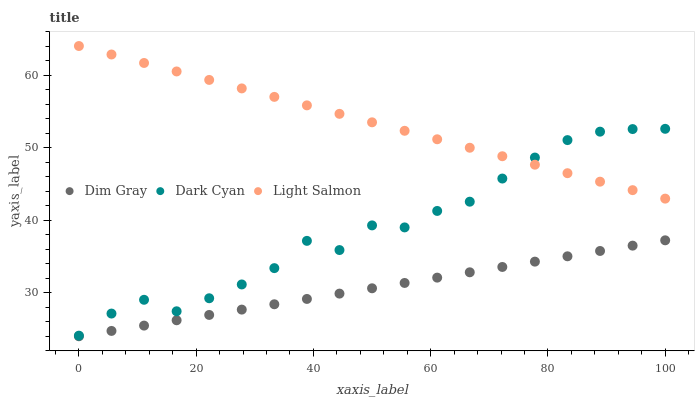Does Dim Gray have the minimum area under the curve?
Answer yes or no. Yes. Does Light Salmon have the maximum area under the curve?
Answer yes or no. Yes. Does Light Salmon have the minimum area under the curve?
Answer yes or no. No. Does Dim Gray have the maximum area under the curve?
Answer yes or no. No. Is Dim Gray the smoothest?
Answer yes or no. Yes. Is Dark Cyan the roughest?
Answer yes or no. Yes. Is Light Salmon the smoothest?
Answer yes or no. No. Is Light Salmon the roughest?
Answer yes or no. No. Does Dim Gray have the lowest value?
Answer yes or no. Yes. Does Light Salmon have the lowest value?
Answer yes or no. No. Does Light Salmon have the highest value?
Answer yes or no. Yes. Does Dim Gray have the highest value?
Answer yes or no. No. Is Dim Gray less than Dark Cyan?
Answer yes or no. Yes. Is Dark Cyan greater than Dim Gray?
Answer yes or no. Yes. Does Light Salmon intersect Dark Cyan?
Answer yes or no. Yes. Is Light Salmon less than Dark Cyan?
Answer yes or no. No. Is Light Salmon greater than Dark Cyan?
Answer yes or no. No. Does Dim Gray intersect Dark Cyan?
Answer yes or no. No. 